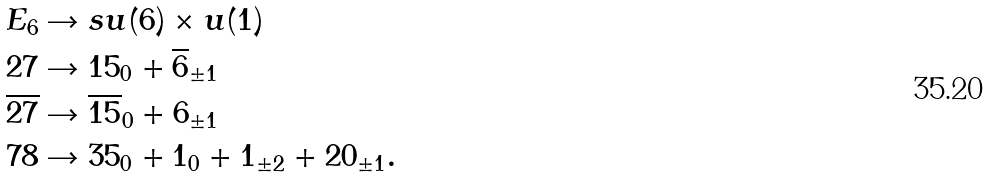<formula> <loc_0><loc_0><loc_500><loc_500>E _ { 6 } & \rightarrow s u ( 6 ) \times u ( 1 ) \\ 2 7 & \rightarrow 1 5 _ { 0 } + \overline { 6 } _ { \pm 1 } \\ \overline { 2 7 } & \rightarrow \overline { 1 5 } _ { 0 } + 6 _ { \pm 1 } \\ 7 8 & \rightarrow 3 5 _ { 0 } + 1 _ { 0 } + 1 _ { \pm 2 } + 2 0 _ { \pm 1 } .</formula> 